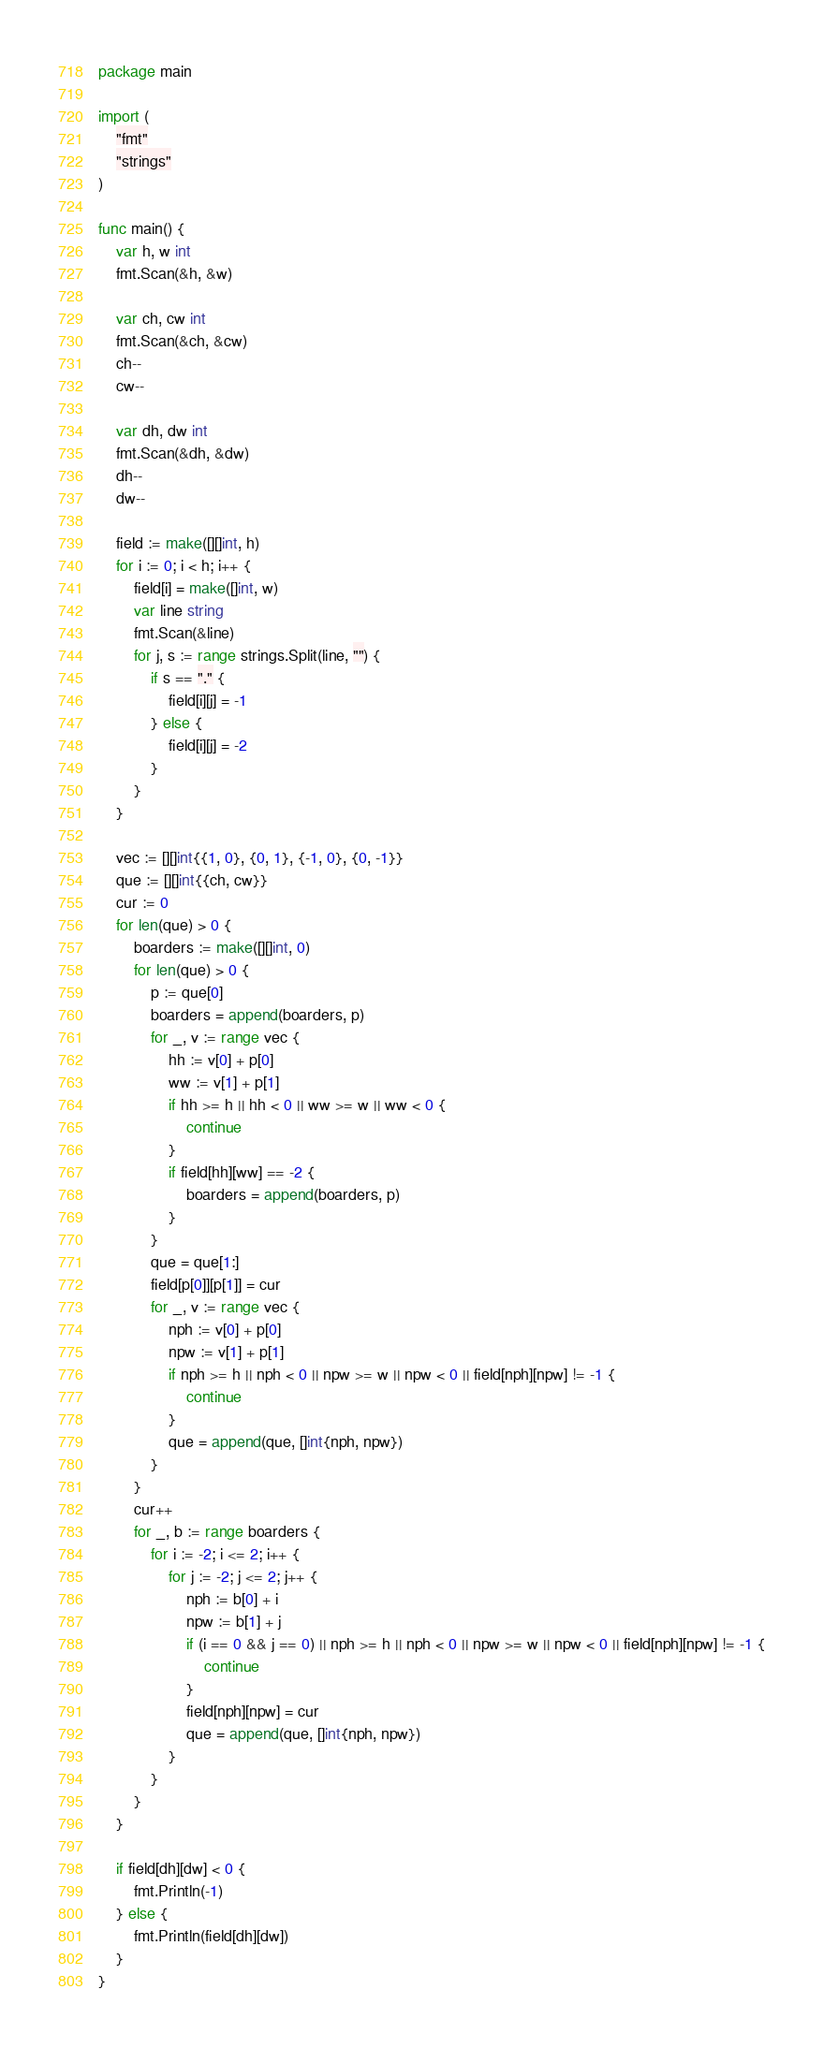<code> <loc_0><loc_0><loc_500><loc_500><_Go_>package main

import (
	"fmt"
	"strings"
)

func main() {
	var h, w int
	fmt.Scan(&h, &w)

	var ch, cw int
	fmt.Scan(&ch, &cw)
	ch--
	cw--

	var dh, dw int
	fmt.Scan(&dh, &dw)
	dh--
	dw--

	field := make([][]int, h)
	for i := 0; i < h; i++ {
		field[i] = make([]int, w)
		var line string
		fmt.Scan(&line)
		for j, s := range strings.Split(line, "") {
			if s == "." {
				field[i][j] = -1
			} else {
				field[i][j] = -2
			}
		}
	}

	vec := [][]int{{1, 0}, {0, 1}, {-1, 0}, {0, -1}}
	que := [][]int{{ch, cw}}
	cur := 0
	for len(que) > 0 {
		boarders := make([][]int, 0)
		for len(que) > 0 {
			p := que[0]
			boarders = append(boarders, p)
			for _, v := range vec {
				hh := v[0] + p[0]
				ww := v[1] + p[1]
				if hh >= h || hh < 0 || ww >= w || ww < 0 {
					continue
				}
				if field[hh][ww] == -2 {
					boarders = append(boarders, p)
				}
			}
			que = que[1:]
			field[p[0]][p[1]] = cur
			for _, v := range vec {
				nph := v[0] + p[0]
				npw := v[1] + p[1]
				if nph >= h || nph < 0 || npw >= w || npw < 0 || field[nph][npw] != -1 {
					continue
				}
				que = append(que, []int{nph, npw})
			}
		}
		cur++
		for _, b := range boarders {
			for i := -2; i <= 2; i++ {
				for j := -2; j <= 2; j++ {
					nph := b[0] + i
					npw := b[1] + j
					if (i == 0 && j == 0) || nph >= h || nph < 0 || npw >= w || npw < 0 || field[nph][npw] != -1 {
						continue
					}
					field[nph][npw] = cur
					que = append(que, []int{nph, npw})
				}
			}
		}
	}

	if field[dh][dw] < 0 {
		fmt.Println(-1)
	} else {
		fmt.Println(field[dh][dw])
	}
}
</code> 